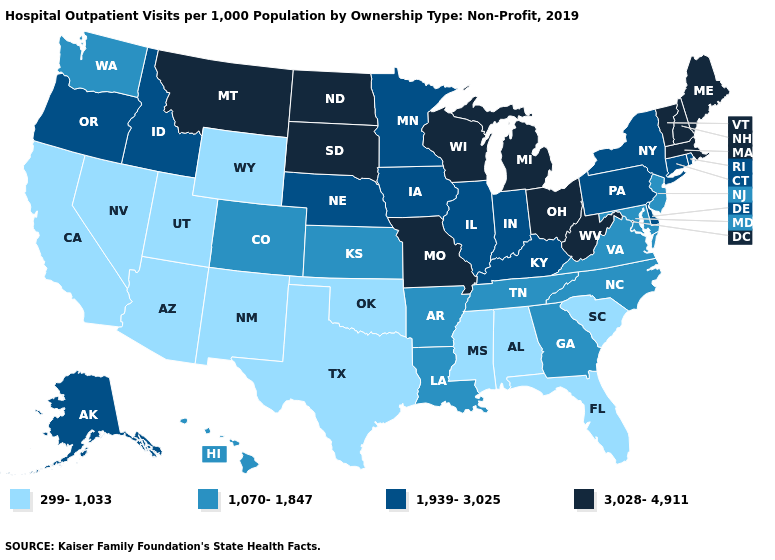What is the value of West Virginia?
Answer briefly. 3,028-4,911. What is the value of Oregon?
Concise answer only. 1,939-3,025. Name the states that have a value in the range 1,939-3,025?
Answer briefly. Alaska, Connecticut, Delaware, Idaho, Illinois, Indiana, Iowa, Kentucky, Minnesota, Nebraska, New York, Oregon, Pennsylvania, Rhode Island. What is the lowest value in the West?
Answer briefly. 299-1,033. Name the states that have a value in the range 299-1,033?
Short answer required. Alabama, Arizona, California, Florida, Mississippi, Nevada, New Mexico, Oklahoma, South Carolina, Texas, Utah, Wyoming. Among the states that border New Hampshire , which have the lowest value?
Concise answer only. Maine, Massachusetts, Vermont. Name the states that have a value in the range 1,070-1,847?
Concise answer only. Arkansas, Colorado, Georgia, Hawaii, Kansas, Louisiana, Maryland, New Jersey, North Carolina, Tennessee, Virginia, Washington. Does West Virginia have the highest value in the South?
Be succinct. Yes. Does Oregon have the same value as New Hampshire?
Short answer required. No. What is the value of Georgia?
Be succinct. 1,070-1,847. What is the value of Vermont?
Be succinct. 3,028-4,911. What is the highest value in states that border Wisconsin?
Keep it brief. 3,028-4,911. Is the legend a continuous bar?
Keep it brief. No. Name the states that have a value in the range 3,028-4,911?
Short answer required. Maine, Massachusetts, Michigan, Missouri, Montana, New Hampshire, North Dakota, Ohio, South Dakota, Vermont, West Virginia, Wisconsin. Name the states that have a value in the range 299-1,033?
Answer briefly. Alabama, Arizona, California, Florida, Mississippi, Nevada, New Mexico, Oklahoma, South Carolina, Texas, Utah, Wyoming. 